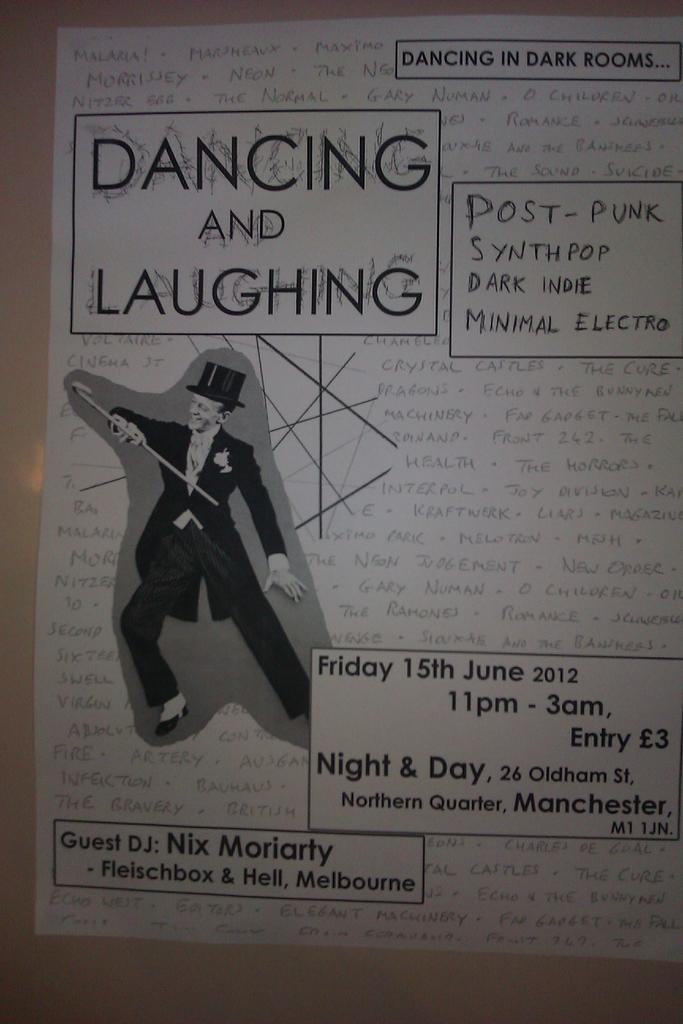<image>
Relay a brief, clear account of the picture shown. Poster showing a man in a top hat dancing which takes place on June 15th. 